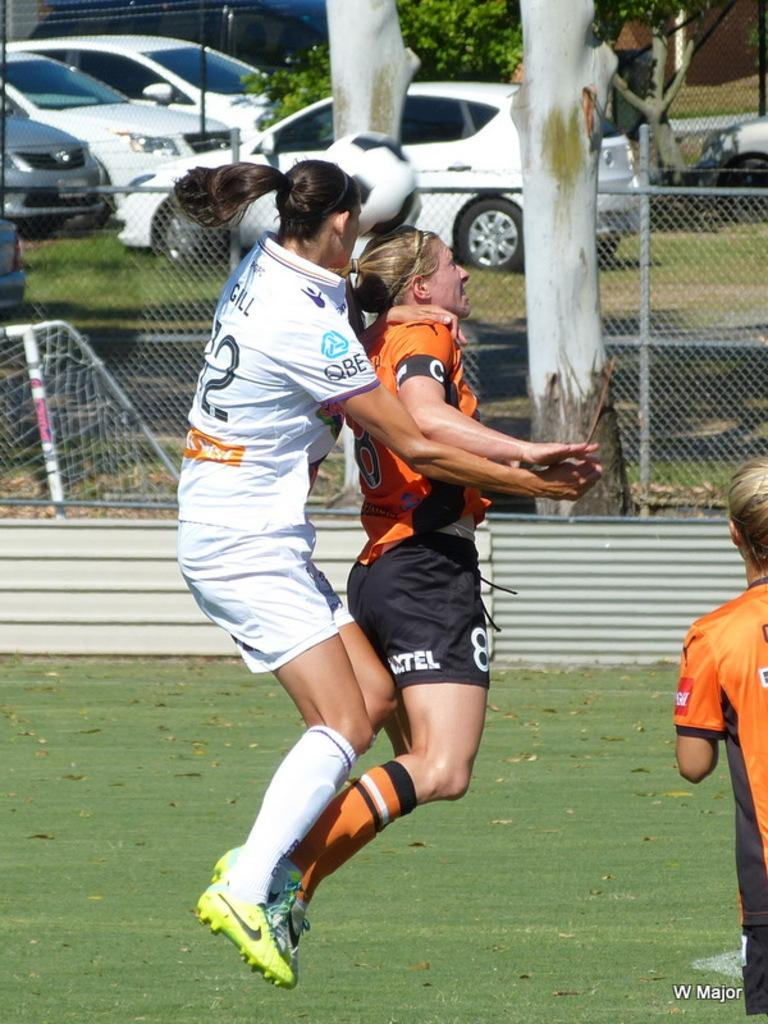How many women are playing football in the image? There are 3 women in the image. What sport are the women playing? The women are playing football. Where is the football game taking place? The football game is taking place on the ground. What can be seen in the background of the image? There are vehicles, trees, and a fence visible in the background. What type of cake is being served to the women during the football game? There is no cake present in the image; the women are playing football on the ground. How many teeth can be seen in the image? There are no teeth visible in the image, as it features women playing football on the ground. 